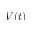<formula> <loc_0><loc_0><loc_500><loc_500>V ( t )</formula> 